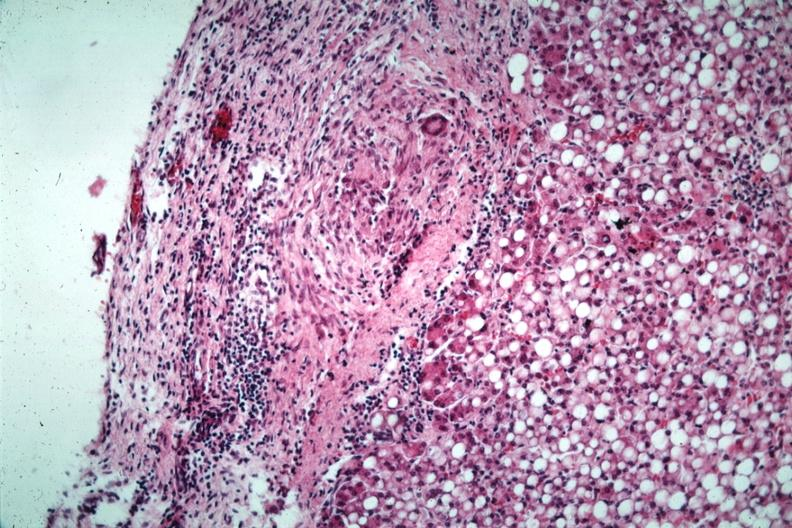what has quite good liver marked?
Answer the question using a single word or phrase. Fatty change 